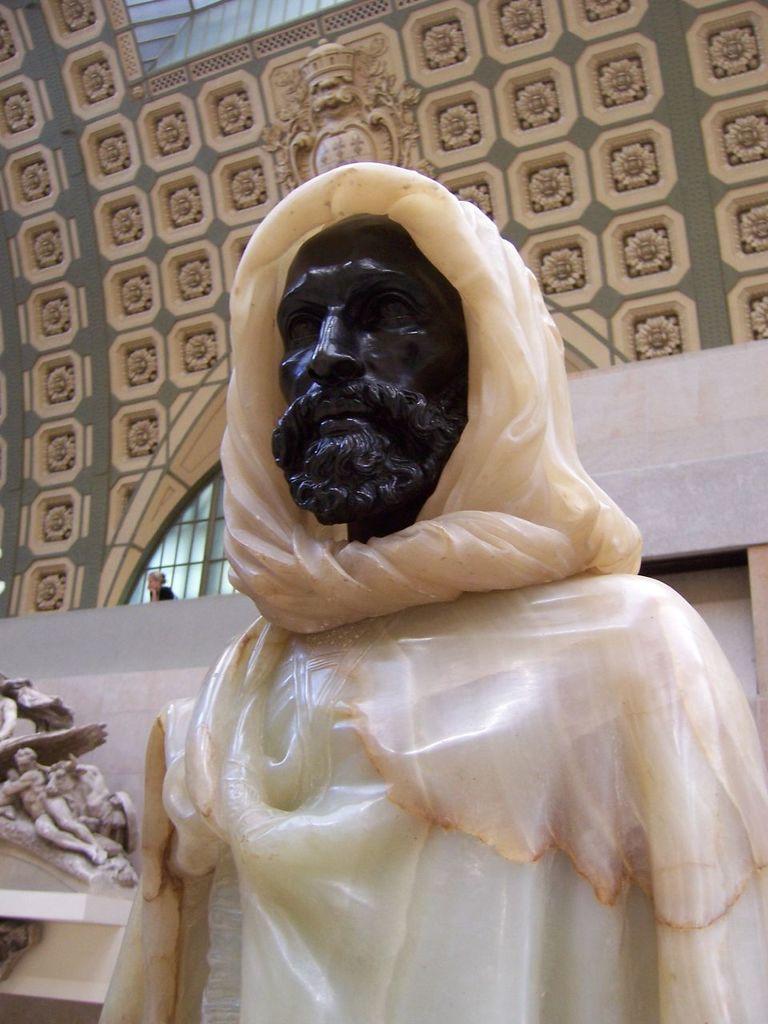Please provide a concise description of this image. In this picture we can see a statue in the front, on the left side there is a sculpture, we can see wall designs in the background. 